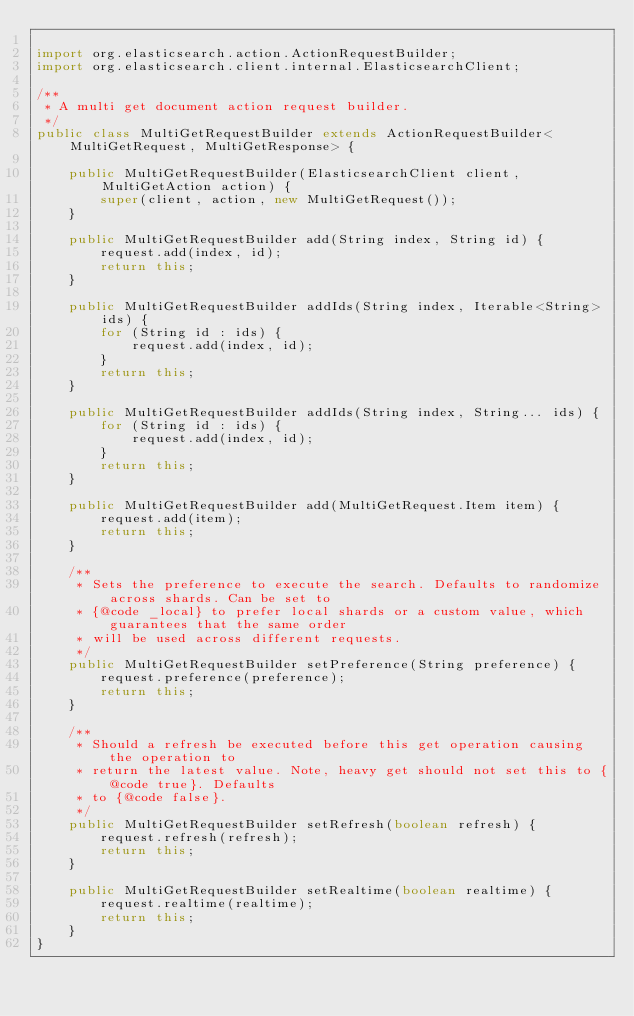Convert code to text. <code><loc_0><loc_0><loc_500><loc_500><_Java_>
import org.elasticsearch.action.ActionRequestBuilder;
import org.elasticsearch.client.internal.ElasticsearchClient;

/**
 * A multi get document action request builder.
 */
public class MultiGetRequestBuilder extends ActionRequestBuilder<MultiGetRequest, MultiGetResponse> {

    public MultiGetRequestBuilder(ElasticsearchClient client, MultiGetAction action) {
        super(client, action, new MultiGetRequest());
    }

    public MultiGetRequestBuilder add(String index, String id) {
        request.add(index, id);
        return this;
    }

    public MultiGetRequestBuilder addIds(String index, Iterable<String> ids) {
        for (String id : ids) {
            request.add(index, id);
        }
        return this;
    }

    public MultiGetRequestBuilder addIds(String index, String... ids) {
        for (String id : ids) {
            request.add(index, id);
        }
        return this;
    }

    public MultiGetRequestBuilder add(MultiGetRequest.Item item) {
        request.add(item);
        return this;
    }

    /**
     * Sets the preference to execute the search. Defaults to randomize across shards. Can be set to
     * {@code _local} to prefer local shards or a custom value, which guarantees that the same order
     * will be used across different requests.
     */
    public MultiGetRequestBuilder setPreference(String preference) {
        request.preference(preference);
        return this;
    }

    /**
     * Should a refresh be executed before this get operation causing the operation to
     * return the latest value. Note, heavy get should not set this to {@code true}. Defaults
     * to {@code false}.
     */
    public MultiGetRequestBuilder setRefresh(boolean refresh) {
        request.refresh(refresh);
        return this;
    }

    public MultiGetRequestBuilder setRealtime(boolean realtime) {
        request.realtime(realtime);
        return this;
    }
}
</code> 